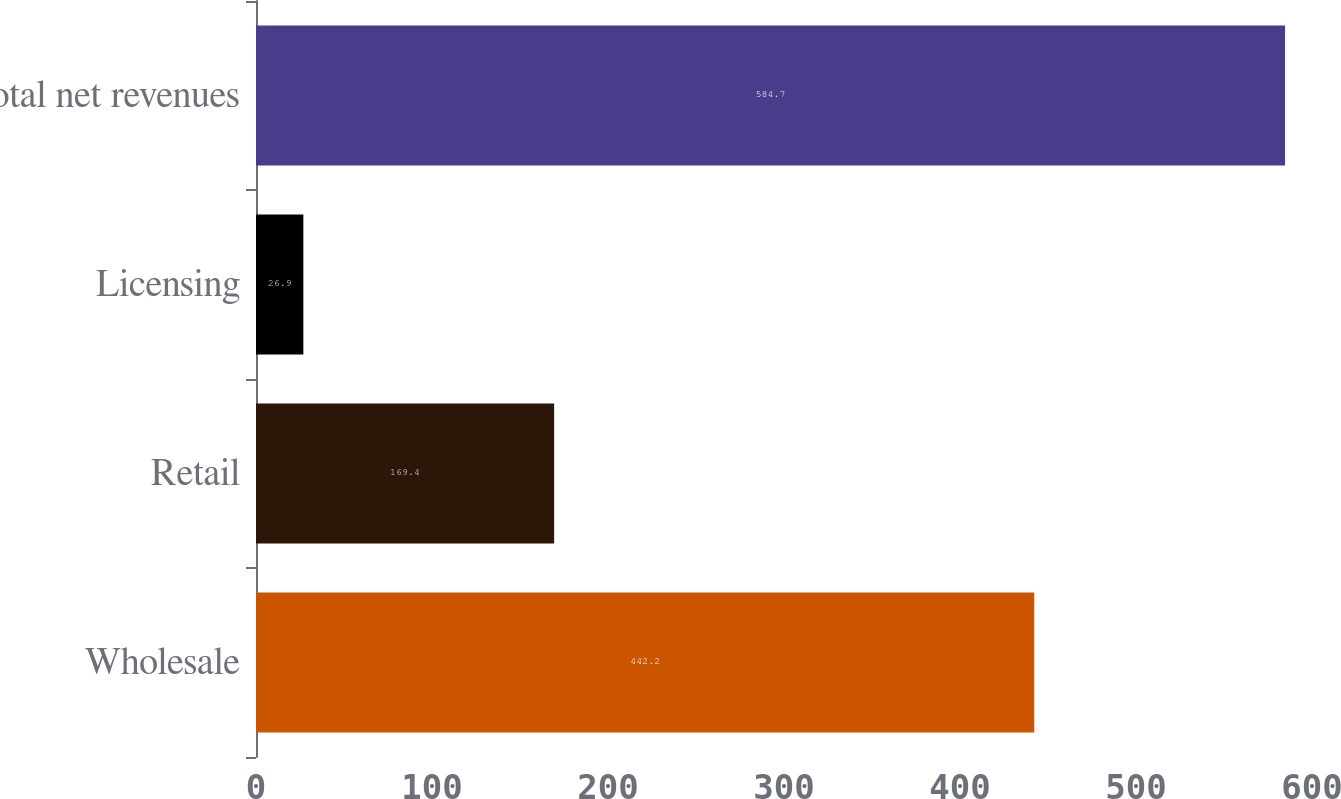<chart> <loc_0><loc_0><loc_500><loc_500><bar_chart><fcel>Wholesale<fcel>Retail<fcel>Licensing<fcel>Total net revenues<nl><fcel>442.2<fcel>169.4<fcel>26.9<fcel>584.7<nl></chart> 